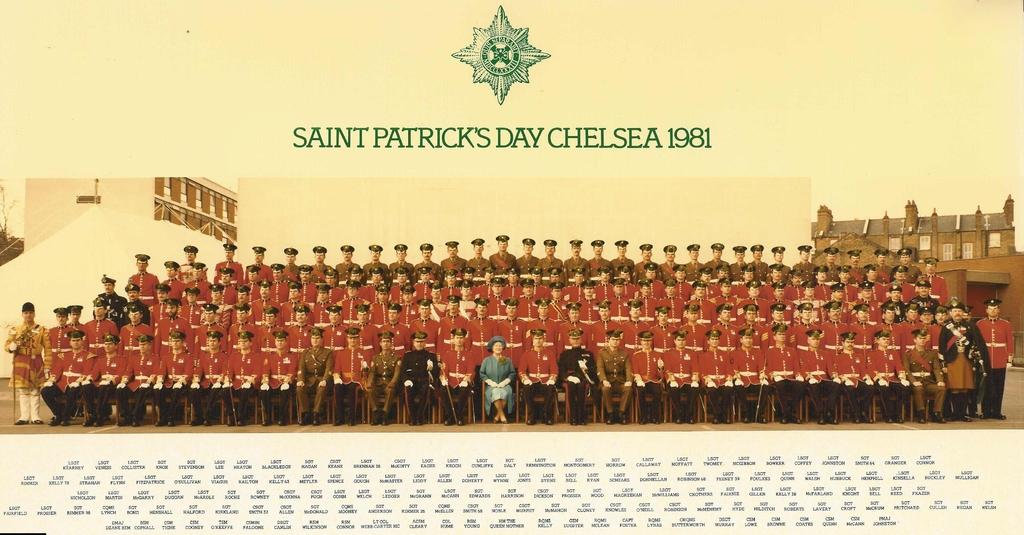<image>
Provide a brief description of the given image. A picture of many men dressed in red military type attire below the words Saint Patrick's Day Chelsea 1981. 